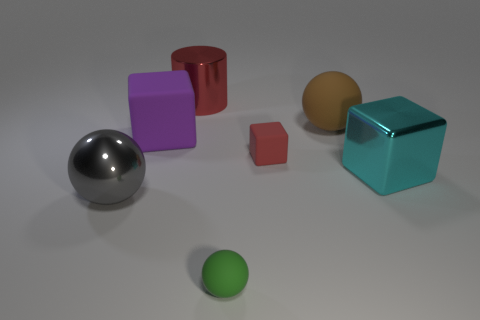Is there anything else that is the same shape as the big red object?
Provide a short and direct response. No. Is the color of the tiny cube the same as the big shiny object behind the cyan cube?
Provide a short and direct response. Yes. Is there another small matte thing of the same shape as the brown matte thing?
Your answer should be very brief. Yes. Do the small block and the cylinder have the same color?
Keep it short and to the point. Yes. Is there a big shiny thing right of the large purple rubber object that is to the left of the big shiny cylinder?
Provide a short and direct response. Yes. How many objects are matte objects to the right of the green sphere or rubber balls in front of the cyan shiny thing?
Provide a succinct answer. 3. How many objects are matte balls or rubber spheres on the right side of the tiny green matte thing?
Your answer should be very brief. 2. There is a matte block in front of the matte cube on the left side of the object that is in front of the big metal ball; what size is it?
Give a very brief answer. Small. There is a brown object that is the same size as the cylinder; what material is it?
Give a very brief answer. Rubber. Is there a brown matte object of the same size as the red metallic cylinder?
Provide a short and direct response. Yes. 